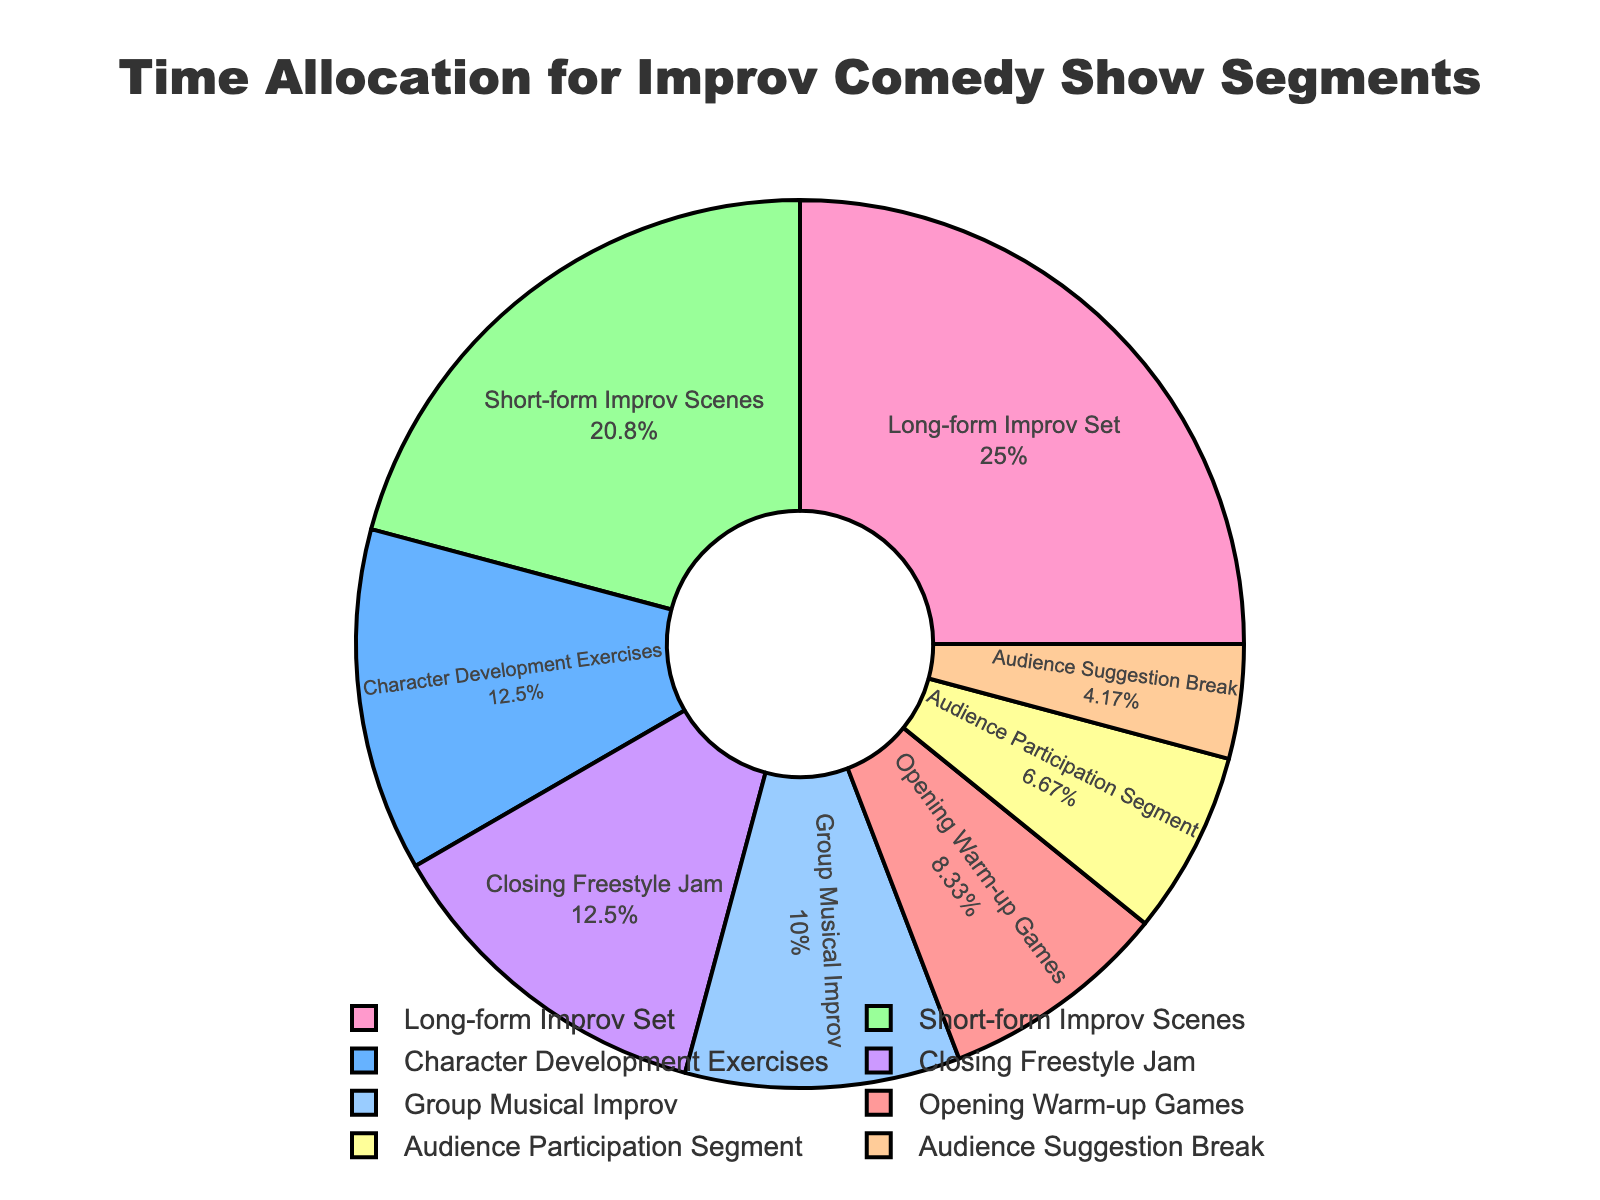what is the segment with the largest time allocation? The segment with the largest time allocation is identified by the largest percentage on the pie chart.
Answer: Long-form Improv Set How much more time is spent on Long-form Improv Set compared to Audience Participation Segment? Find the time allocated for Long-form Improv Set and Audience Participation Segment and calculate the difference. Long-form Improv Set is 30 minutes, and Audience Participation Segment is 8 minutes. 30 - 8 = 22 minutes.
Answer: 22 minutes Which segment takes up the least amount of time? Identify the segment with the smallest percentage on the pie chart.
Answer: Audience Suggestion Break What proportion of the show is dedicated to musical segments (Group Musical Improv and Closing Freestyle Jam)? Sum the time of Group Musical Improv (12 minutes) and Closing Freestyle Jam (15 minutes), then calculate the combined percentage out of the total show time. Combined time = 12 + 15 = 27 minutes.
Answer: 27 minutes Are more minutes spent on Character Development Exercises or Group Musical Improv? Compare the time allocated for both segments. Character Development Exercises is 15 minutes, and Group Musical Improv is 12 minutes.
Answer: Character Development Exercises What is the combined percentage of time allocated to Opening Warm-up Games and Short-form Improv Scenes? Add the percentages of Opening Warm-up Games and Short-form Improv Scenes. Find their times (10 minutes and 25 minutes respectively) and calculate the percentage of each out of the total 120 minutes. Opening Warm-up Games = (10/120) * 100 = 8.33%, and Short-form Improv Scenes = (25/120) * 100 = 20.83%. Sum = 8.33 + 20.83 = 29.16%.
Answer: 29.16% Is the time spent on Long-form Improv Set greater than the sum of Opening Warm-up Games and Audience Suggestion Break? Calculate the sum of Opening Warm-up Games (10 minutes) and Audience Suggestion Break (5 minutes). 10 + 5 = 15 minutes. Compare this with Long-form Improv Set (30 minutes).
Answer: Yes, it is greater What segment has an approximately equal time allocation to Closing Freestyle Jam? Look for a segment with a similar percentage/time to 15 minutes which is allocated to Closing Freestyle Jam.
Answer: Character Development Exercises 